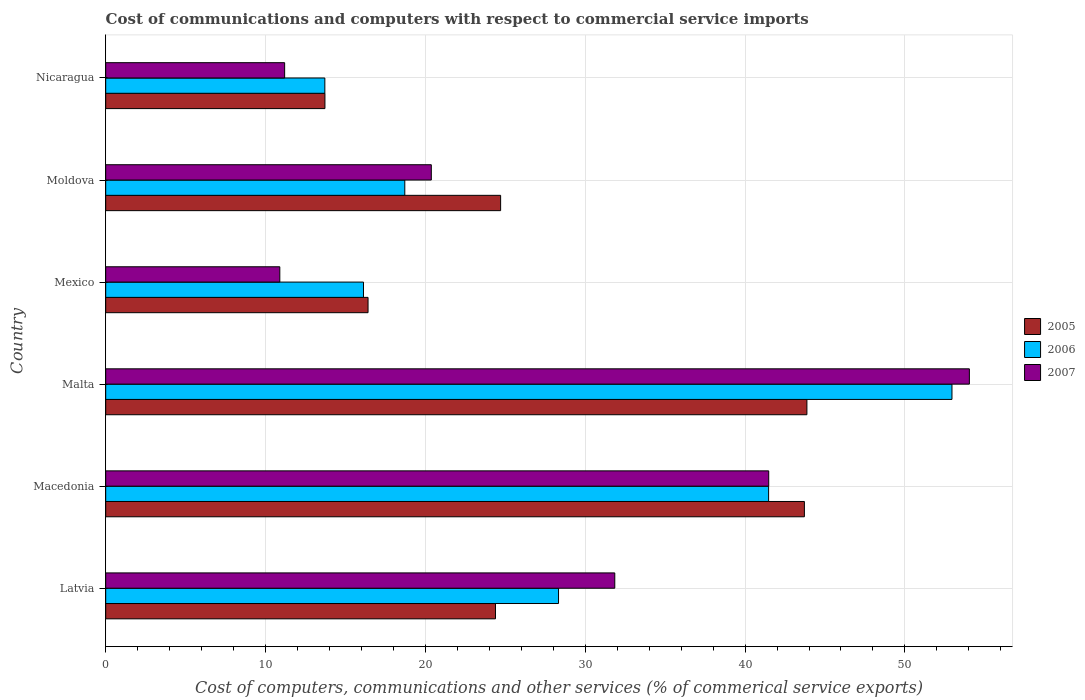What is the label of the 5th group of bars from the top?
Provide a succinct answer. Macedonia. In how many cases, is the number of bars for a given country not equal to the number of legend labels?
Keep it short and to the point. 0. What is the cost of communications and computers in 2007 in Nicaragua?
Make the answer very short. 11.2. Across all countries, what is the maximum cost of communications and computers in 2007?
Your answer should be compact. 54.03. Across all countries, what is the minimum cost of communications and computers in 2005?
Offer a terse response. 13.72. In which country was the cost of communications and computers in 2006 maximum?
Offer a terse response. Malta. What is the total cost of communications and computers in 2006 in the graph?
Offer a terse response. 171.3. What is the difference between the cost of communications and computers in 2005 in Malta and that in Moldova?
Give a very brief answer. 19.16. What is the difference between the cost of communications and computers in 2005 in Nicaragua and the cost of communications and computers in 2007 in Macedonia?
Offer a terse response. -27.76. What is the average cost of communications and computers in 2006 per country?
Keep it short and to the point. 28.55. What is the difference between the cost of communications and computers in 2005 and cost of communications and computers in 2007 in Nicaragua?
Offer a terse response. 2.52. In how many countries, is the cost of communications and computers in 2005 greater than 2 %?
Your response must be concise. 6. What is the ratio of the cost of communications and computers in 2005 in Macedonia to that in Mexico?
Offer a terse response. 2.66. Is the cost of communications and computers in 2005 in Malta less than that in Nicaragua?
Give a very brief answer. No. Is the difference between the cost of communications and computers in 2005 in Malta and Mexico greater than the difference between the cost of communications and computers in 2007 in Malta and Mexico?
Give a very brief answer. No. What is the difference between the highest and the second highest cost of communications and computers in 2007?
Ensure brevity in your answer.  12.55. What is the difference between the highest and the lowest cost of communications and computers in 2005?
Make the answer very short. 30.15. In how many countries, is the cost of communications and computers in 2007 greater than the average cost of communications and computers in 2007 taken over all countries?
Your answer should be very brief. 3. What does the 1st bar from the bottom in Macedonia represents?
Keep it short and to the point. 2005. How many countries are there in the graph?
Your answer should be compact. 6. Are the values on the major ticks of X-axis written in scientific E-notation?
Make the answer very short. No. Does the graph contain any zero values?
Provide a succinct answer. No. Where does the legend appear in the graph?
Your response must be concise. Center right. How many legend labels are there?
Give a very brief answer. 3. How are the legend labels stacked?
Offer a very short reply. Vertical. What is the title of the graph?
Make the answer very short. Cost of communications and computers with respect to commercial service imports. Does "2015" appear as one of the legend labels in the graph?
Offer a terse response. No. What is the label or title of the X-axis?
Make the answer very short. Cost of computers, communications and other services (% of commerical service exports). What is the label or title of the Y-axis?
Make the answer very short. Country. What is the Cost of computers, communications and other services (% of commerical service exports) in 2005 in Latvia?
Keep it short and to the point. 24.39. What is the Cost of computers, communications and other services (% of commerical service exports) of 2006 in Latvia?
Make the answer very short. 28.33. What is the Cost of computers, communications and other services (% of commerical service exports) of 2007 in Latvia?
Give a very brief answer. 31.85. What is the Cost of computers, communications and other services (% of commerical service exports) in 2005 in Macedonia?
Your answer should be very brief. 43.71. What is the Cost of computers, communications and other services (% of commerical service exports) in 2006 in Macedonia?
Keep it short and to the point. 41.47. What is the Cost of computers, communications and other services (% of commerical service exports) of 2007 in Macedonia?
Provide a short and direct response. 41.48. What is the Cost of computers, communications and other services (% of commerical service exports) in 2005 in Malta?
Make the answer very short. 43.87. What is the Cost of computers, communications and other services (% of commerical service exports) in 2006 in Malta?
Keep it short and to the point. 52.94. What is the Cost of computers, communications and other services (% of commerical service exports) of 2007 in Malta?
Your answer should be compact. 54.03. What is the Cost of computers, communications and other services (% of commerical service exports) in 2005 in Mexico?
Provide a short and direct response. 16.41. What is the Cost of computers, communications and other services (% of commerical service exports) of 2006 in Mexico?
Provide a short and direct response. 16.13. What is the Cost of computers, communications and other services (% of commerical service exports) of 2007 in Mexico?
Your response must be concise. 10.89. What is the Cost of computers, communications and other services (% of commerical service exports) in 2005 in Moldova?
Your response must be concise. 24.71. What is the Cost of computers, communications and other services (% of commerical service exports) of 2006 in Moldova?
Give a very brief answer. 18.71. What is the Cost of computers, communications and other services (% of commerical service exports) of 2007 in Moldova?
Provide a short and direct response. 20.37. What is the Cost of computers, communications and other services (% of commerical service exports) of 2005 in Nicaragua?
Your answer should be compact. 13.72. What is the Cost of computers, communications and other services (% of commerical service exports) of 2006 in Nicaragua?
Ensure brevity in your answer.  13.71. What is the Cost of computers, communications and other services (% of commerical service exports) of 2007 in Nicaragua?
Your response must be concise. 11.2. Across all countries, what is the maximum Cost of computers, communications and other services (% of commerical service exports) in 2005?
Your answer should be very brief. 43.87. Across all countries, what is the maximum Cost of computers, communications and other services (% of commerical service exports) of 2006?
Provide a short and direct response. 52.94. Across all countries, what is the maximum Cost of computers, communications and other services (% of commerical service exports) of 2007?
Keep it short and to the point. 54.03. Across all countries, what is the minimum Cost of computers, communications and other services (% of commerical service exports) in 2005?
Provide a succinct answer. 13.72. Across all countries, what is the minimum Cost of computers, communications and other services (% of commerical service exports) in 2006?
Keep it short and to the point. 13.71. Across all countries, what is the minimum Cost of computers, communications and other services (% of commerical service exports) of 2007?
Provide a short and direct response. 10.89. What is the total Cost of computers, communications and other services (% of commerical service exports) of 2005 in the graph?
Your answer should be very brief. 166.8. What is the total Cost of computers, communications and other services (% of commerical service exports) of 2006 in the graph?
Give a very brief answer. 171.3. What is the total Cost of computers, communications and other services (% of commerical service exports) of 2007 in the graph?
Keep it short and to the point. 169.82. What is the difference between the Cost of computers, communications and other services (% of commerical service exports) of 2005 in Latvia and that in Macedonia?
Your answer should be very brief. -19.32. What is the difference between the Cost of computers, communications and other services (% of commerical service exports) in 2006 in Latvia and that in Macedonia?
Offer a very short reply. -13.14. What is the difference between the Cost of computers, communications and other services (% of commerical service exports) of 2007 in Latvia and that in Macedonia?
Ensure brevity in your answer.  -9.63. What is the difference between the Cost of computers, communications and other services (% of commerical service exports) of 2005 in Latvia and that in Malta?
Your response must be concise. -19.48. What is the difference between the Cost of computers, communications and other services (% of commerical service exports) in 2006 in Latvia and that in Malta?
Keep it short and to the point. -24.61. What is the difference between the Cost of computers, communications and other services (% of commerical service exports) in 2007 in Latvia and that in Malta?
Provide a short and direct response. -22.18. What is the difference between the Cost of computers, communications and other services (% of commerical service exports) in 2005 in Latvia and that in Mexico?
Give a very brief answer. 7.97. What is the difference between the Cost of computers, communications and other services (% of commerical service exports) in 2006 in Latvia and that in Mexico?
Your answer should be very brief. 12.2. What is the difference between the Cost of computers, communications and other services (% of commerical service exports) in 2007 in Latvia and that in Mexico?
Make the answer very short. 20.96. What is the difference between the Cost of computers, communications and other services (% of commerical service exports) in 2005 in Latvia and that in Moldova?
Provide a short and direct response. -0.32. What is the difference between the Cost of computers, communications and other services (% of commerical service exports) in 2006 in Latvia and that in Moldova?
Your answer should be very brief. 9.62. What is the difference between the Cost of computers, communications and other services (% of commerical service exports) of 2007 in Latvia and that in Moldova?
Offer a terse response. 11.48. What is the difference between the Cost of computers, communications and other services (% of commerical service exports) of 2005 in Latvia and that in Nicaragua?
Keep it short and to the point. 10.67. What is the difference between the Cost of computers, communications and other services (% of commerical service exports) of 2006 in Latvia and that in Nicaragua?
Offer a very short reply. 14.62. What is the difference between the Cost of computers, communications and other services (% of commerical service exports) of 2007 in Latvia and that in Nicaragua?
Provide a succinct answer. 20.65. What is the difference between the Cost of computers, communications and other services (% of commerical service exports) in 2005 in Macedonia and that in Malta?
Offer a very short reply. -0.16. What is the difference between the Cost of computers, communications and other services (% of commerical service exports) of 2006 in Macedonia and that in Malta?
Your response must be concise. -11.47. What is the difference between the Cost of computers, communications and other services (% of commerical service exports) of 2007 in Macedonia and that in Malta?
Ensure brevity in your answer.  -12.55. What is the difference between the Cost of computers, communications and other services (% of commerical service exports) in 2005 in Macedonia and that in Mexico?
Your answer should be compact. 27.3. What is the difference between the Cost of computers, communications and other services (% of commerical service exports) in 2006 in Macedonia and that in Mexico?
Keep it short and to the point. 25.35. What is the difference between the Cost of computers, communications and other services (% of commerical service exports) in 2007 in Macedonia and that in Mexico?
Provide a short and direct response. 30.59. What is the difference between the Cost of computers, communications and other services (% of commerical service exports) in 2005 in Macedonia and that in Moldova?
Your answer should be compact. 19. What is the difference between the Cost of computers, communications and other services (% of commerical service exports) in 2006 in Macedonia and that in Moldova?
Your answer should be very brief. 22.76. What is the difference between the Cost of computers, communications and other services (% of commerical service exports) in 2007 in Macedonia and that in Moldova?
Your response must be concise. 21.11. What is the difference between the Cost of computers, communications and other services (% of commerical service exports) of 2005 in Macedonia and that in Nicaragua?
Your answer should be compact. 30. What is the difference between the Cost of computers, communications and other services (% of commerical service exports) of 2006 in Macedonia and that in Nicaragua?
Give a very brief answer. 27.76. What is the difference between the Cost of computers, communications and other services (% of commerical service exports) in 2007 in Macedonia and that in Nicaragua?
Your response must be concise. 30.29. What is the difference between the Cost of computers, communications and other services (% of commerical service exports) in 2005 in Malta and that in Mexico?
Give a very brief answer. 27.46. What is the difference between the Cost of computers, communications and other services (% of commerical service exports) in 2006 in Malta and that in Mexico?
Your answer should be very brief. 36.82. What is the difference between the Cost of computers, communications and other services (% of commerical service exports) of 2007 in Malta and that in Mexico?
Your answer should be very brief. 43.14. What is the difference between the Cost of computers, communications and other services (% of commerical service exports) in 2005 in Malta and that in Moldova?
Give a very brief answer. 19.16. What is the difference between the Cost of computers, communications and other services (% of commerical service exports) of 2006 in Malta and that in Moldova?
Offer a very short reply. 34.23. What is the difference between the Cost of computers, communications and other services (% of commerical service exports) in 2007 in Malta and that in Moldova?
Your answer should be compact. 33.66. What is the difference between the Cost of computers, communications and other services (% of commerical service exports) in 2005 in Malta and that in Nicaragua?
Provide a succinct answer. 30.15. What is the difference between the Cost of computers, communications and other services (% of commerical service exports) of 2006 in Malta and that in Nicaragua?
Give a very brief answer. 39.23. What is the difference between the Cost of computers, communications and other services (% of commerical service exports) of 2007 in Malta and that in Nicaragua?
Provide a short and direct response. 42.84. What is the difference between the Cost of computers, communications and other services (% of commerical service exports) of 2005 in Mexico and that in Moldova?
Provide a short and direct response. -8.29. What is the difference between the Cost of computers, communications and other services (% of commerical service exports) in 2006 in Mexico and that in Moldova?
Give a very brief answer. -2.58. What is the difference between the Cost of computers, communications and other services (% of commerical service exports) in 2007 in Mexico and that in Moldova?
Your answer should be very brief. -9.48. What is the difference between the Cost of computers, communications and other services (% of commerical service exports) of 2005 in Mexico and that in Nicaragua?
Give a very brief answer. 2.7. What is the difference between the Cost of computers, communications and other services (% of commerical service exports) in 2006 in Mexico and that in Nicaragua?
Make the answer very short. 2.42. What is the difference between the Cost of computers, communications and other services (% of commerical service exports) of 2007 in Mexico and that in Nicaragua?
Your answer should be compact. -0.3. What is the difference between the Cost of computers, communications and other services (% of commerical service exports) in 2005 in Moldova and that in Nicaragua?
Keep it short and to the point. 10.99. What is the difference between the Cost of computers, communications and other services (% of commerical service exports) of 2006 in Moldova and that in Nicaragua?
Provide a succinct answer. 5. What is the difference between the Cost of computers, communications and other services (% of commerical service exports) of 2007 in Moldova and that in Nicaragua?
Offer a terse response. 9.18. What is the difference between the Cost of computers, communications and other services (% of commerical service exports) of 2005 in Latvia and the Cost of computers, communications and other services (% of commerical service exports) of 2006 in Macedonia?
Offer a terse response. -17.09. What is the difference between the Cost of computers, communications and other services (% of commerical service exports) in 2005 in Latvia and the Cost of computers, communications and other services (% of commerical service exports) in 2007 in Macedonia?
Your response must be concise. -17.09. What is the difference between the Cost of computers, communications and other services (% of commerical service exports) of 2006 in Latvia and the Cost of computers, communications and other services (% of commerical service exports) of 2007 in Macedonia?
Ensure brevity in your answer.  -13.15. What is the difference between the Cost of computers, communications and other services (% of commerical service exports) in 2005 in Latvia and the Cost of computers, communications and other services (% of commerical service exports) in 2006 in Malta?
Provide a succinct answer. -28.56. What is the difference between the Cost of computers, communications and other services (% of commerical service exports) of 2005 in Latvia and the Cost of computers, communications and other services (% of commerical service exports) of 2007 in Malta?
Give a very brief answer. -29.65. What is the difference between the Cost of computers, communications and other services (% of commerical service exports) in 2006 in Latvia and the Cost of computers, communications and other services (% of commerical service exports) in 2007 in Malta?
Provide a short and direct response. -25.7. What is the difference between the Cost of computers, communications and other services (% of commerical service exports) in 2005 in Latvia and the Cost of computers, communications and other services (% of commerical service exports) in 2006 in Mexico?
Keep it short and to the point. 8.26. What is the difference between the Cost of computers, communications and other services (% of commerical service exports) in 2005 in Latvia and the Cost of computers, communications and other services (% of commerical service exports) in 2007 in Mexico?
Offer a terse response. 13.49. What is the difference between the Cost of computers, communications and other services (% of commerical service exports) in 2006 in Latvia and the Cost of computers, communications and other services (% of commerical service exports) in 2007 in Mexico?
Make the answer very short. 17.44. What is the difference between the Cost of computers, communications and other services (% of commerical service exports) of 2005 in Latvia and the Cost of computers, communications and other services (% of commerical service exports) of 2006 in Moldova?
Give a very brief answer. 5.67. What is the difference between the Cost of computers, communications and other services (% of commerical service exports) of 2005 in Latvia and the Cost of computers, communications and other services (% of commerical service exports) of 2007 in Moldova?
Offer a very short reply. 4.02. What is the difference between the Cost of computers, communications and other services (% of commerical service exports) of 2006 in Latvia and the Cost of computers, communications and other services (% of commerical service exports) of 2007 in Moldova?
Offer a terse response. 7.96. What is the difference between the Cost of computers, communications and other services (% of commerical service exports) of 2005 in Latvia and the Cost of computers, communications and other services (% of commerical service exports) of 2006 in Nicaragua?
Ensure brevity in your answer.  10.68. What is the difference between the Cost of computers, communications and other services (% of commerical service exports) of 2005 in Latvia and the Cost of computers, communications and other services (% of commerical service exports) of 2007 in Nicaragua?
Make the answer very short. 13.19. What is the difference between the Cost of computers, communications and other services (% of commerical service exports) in 2006 in Latvia and the Cost of computers, communications and other services (% of commerical service exports) in 2007 in Nicaragua?
Your answer should be compact. 17.14. What is the difference between the Cost of computers, communications and other services (% of commerical service exports) of 2005 in Macedonia and the Cost of computers, communications and other services (% of commerical service exports) of 2006 in Malta?
Offer a very short reply. -9.23. What is the difference between the Cost of computers, communications and other services (% of commerical service exports) in 2005 in Macedonia and the Cost of computers, communications and other services (% of commerical service exports) in 2007 in Malta?
Offer a very short reply. -10.32. What is the difference between the Cost of computers, communications and other services (% of commerical service exports) of 2006 in Macedonia and the Cost of computers, communications and other services (% of commerical service exports) of 2007 in Malta?
Your response must be concise. -12.56. What is the difference between the Cost of computers, communications and other services (% of commerical service exports) in 2005 in Macedonia and the Cost of computers, communications and other services (% of commerical service exports) in 2006 in Mexico?
Ensure brevity in your answer.  27.58. What is the difference between the Cost of computers, communications and other services (% of commerical service exports) in 2005 in Macedonia and the Cost of computers, communications and other services (% of commerical service exports) in 2007 in Mexico?
Give a very brief answer. 32.82. What is the difference between the Cost of computers, communications and other services (% of commerical service exports) of 2006 in Macedonia and the Cost of computers, communications and other services (% of commerical service exports) of 2007 in Mexico?
Keep it short and to the point. 30.58. What is the difference between the Cost of computers, communications and other services (% of commerical service exports) in 2005 in Macedonia and the Cost of computers, communications and other services (% of commerical service exports) in 2006 in Moldova?
Offer a very short reply. 25. What is the difference between the Cost of computers, communications and other services (% of commerical service exports) of 2005 in Macedonia and the Cost of computers, communications and other services (% of commerical service exports) of 2007 in Moldova?
Make the answer very short. 23.34. What is the difference between the Cost of computers, communications and other services (% of commerical service exports) of 2006 in Macedonia and the Cost of computers, communications and other services (% of commerical service exports) of 2007 in Moldova?
Make the answer very short. 21.1. What is the difference between the Cost of computers, communications and other services (% of commerical service exports) of 2005 in Macedonia and the Cost of computers, communications and other services (% of commerical service exports) of 2006 in Nicaragua?
Provide a succinct answer. 30. What is the difference between the Cost of computers, communications and other services (% of commerical service exports) in 2005 in Macedonia and the Cost of computers, communications and other services (% of commerical service exports) in 2007 in Nicaragua?
Offer a very short reply. 32.52. What is the difference between the Cost of computers, communications and other services (% of commerical service exports) of 2006 in Macedonia and the Cost of computers, communications and other services (% of commerical service exports) of 2007 in Nicaragua?
Keep it short and to the point. 30.28. What is the difference between the Cost of computers, communications and other services (% of commerical service exports) of 2005 in Malta and the Cost of computers, communications and other services (% of commerical service exports) of 2006 in Mexico?
Your answer should be compact. 27.74. What is the difference between the Cost of computers, communications and other services (% of commerical service exports) in 2005 in Malta and the Cost of computers, communications and other services (% of commerical service exports) in 2007 in Mexico?
Offer a very short reply. 32.98. What is the difference between the Cost of computers, communications and other services (% of commerical service exports) in 2006 in Malta and the Cost of computers, communications and other services (% of commerical service exports) in 2007 in Mexico?
Offer a terse response. 42.05. What is the difference between the Cost of computers, communications and other services (% of commerical service exports) of 2005 in Malta and the Cost of computers, communications and other services (% of commerical service exports) of 2006 in Moldova?
Give a very brief answer. 25.16. What is the difference between the Cost of computers, communications and other services (% of commerical service exports) of 2005 in Malta and the Cost of computers, communications and other services (% of commerical service exports) of 2007 in Moldova?
Offer a very short reply. 23.5. What is the difference between the Cost of computers, communications and other services (% of commerical service exports) in 2006 in Malta and the Cost of computers, communications and other services (% of commerical service exports) in 2007 in Moldova?
Provide a succinct answer. 32.57. What is the difference between the Cost of computers, communications and other services (% of commerical service exports) of 2005 in Malta and the Cost of computers, communications and other services (% of commerical service exports) of 2006 in Nicaragua?
Make the answer very short. 30.16. What is the difference between the Cost of computers, communications and other services (% of commerical service exports) of 2005 in Malta and the Cost of computers, communications and other services (% of commerical service exports) of 2007 in Nicaragua?
Ensure brevity in your answer.  32.67. What is the difference between the Cost of computers, communications and other services (% of commerical service exports) in 2006 in Malta and the Cost of computers, communications and other services (% of commerical service exports) in 2007 in Nicaragua?
Provide a succinct answer. 41.75. What is the difference between the Cost of computers, communications and other services (% of commerical service exports) of 2005 in Mexico and the Cost of computers, communications and other services (% of commerical service exports) of 2006 in Moldova?
Offer a very short reply. -2.3. What is the difference between the Cost of computers, communications and other services (% of commerical service exports) in 2005 in Mexico and the Cost of computers, communications and other services (% of commerical service exports) in 2007 in Moldova?
Your response must be concise. -3.96. What is the difference between the Cost of computers, communications and other services (% of commerical service exports) of 2006 in Mexico and the Cost of computers, communications and other services (% of commerical service exports) of 2007 in Moldova?
Offer a terse response. -4.24. What is the difference between the Cost of computers, communications and other services (% of commerical service exports) in 2005 in Mexico and the Cost of computers, communications and other services (% of commerical service exports) in 2006 in Nicaragua?
Your answer should be compact. 2.7. What is the difference between the Cost of computers, communications and other services (% of commerical service exports) in 2005 in Mexico and the Cost of computers, communications and other services (% of commerical service exports) in 2007 in Nicaragua?
Give a very brief answer. 5.22. What is the difference between the Cost of computers, communications and other services (% of commerical service exports) of 2006 in Mexico and the Cost of computers, communications and other services (% of commerical service exports) of 2007 in Nicaragua?
Offer a terse response. 4.93. What is the difference between the Cost of computers, communications and other services (% of commerical service exports) in 2005 in Moldova and the Cost of computers, communications and other services (% of commerical service exports) in 2006 in Nicaragua?
Make the answer very short. 11. What is the difference between the Cost of computers, communications and other services (% of commerical service exports) of 2005 in Moldova and the Cost of computers, communications and other services (% of commerical service exports) of 2007 in Nicaragua?
Your response must be concise. 13.51. What is the difference between the Cost of computers, communications and other services (% of commerical service exports) of 2006 in Moldova and the Cost of computers, communications and other services (% of commerical service exports) of 2007 in Nicaragua?
Provide a succinct answer. 7.52. What is the average Cost of computers, communications and other services (% of commerical service exports) of 2005 per country?
Offer a terse response. 27.8. What is the average Cost of computers, communications and other services (% of commerical service exports) in 2006 per country?
Keep it short and to the point. 28.55. What is the average Cost of computers, communications and other services (% of commerical service exports) of 2007 per country?
Provide a short and direct response. 28.3. What is the difference between the Cost of computers, communications and other services (% of commerical service exports) of 2005 and Cost of computers, communications and other services (% of commerical service exports) of 2006 in Latvia?
Ensure brevity in your answer.  -3.94. What is the difference between the Cost of computers, communications and other services (% of commerical service exports) of 2005 and Cost of computers, communications and other services (% of commerical service exports) of 2007 in Latvia?
Your answer should be compact. -7.46. What is the difference between the Cost of computers, communications and other services (% of commerical service exports) of 2006 and Cost of computers, communications and other services (% of commerical service exports) of 2007 in Latvia?
Provide a short and direct response. -3.52. What is the difference between the Cost of computers, communications and other services (% of commerical service exports) of 2005 and Cost of computers, communications and other services (% of commerical service exports) of 2006 in Macedonia?
Your answer should be compact. 2.24. What is the difference between the Cost of computers, communications and other services (% of commerical service exports) in 2005 and Cost of computers, communications and other services (% of commerical service exports) in 2007 in Macedonia?
Provide a short and direct response. 2.23. What is the difference between the Cost of computers, communications and other services (% of commerical service exports) in 2006 and Cost of computers, communications and other services (% of commerical service exports) in 2007 in Macedonia?
Your answer should be very brief. -0.01. What is the difference between the Cost of computers, communications and other services (% of commerical service exports) of 2005 and Cost of computers, communications and other services (% of commerical service exports) of 2006 in Malta?
Your answer should be very brief. -9.08. What is the difference between the Cost of computers, communications and other services (% of commerical service exports) of 2005 and Cost of computers, communications and other services (% of commerical service exports) of 2007 in Malta?
Offer a terse response. -10.16. What is the difference between the Cost of computers, communications and other services (% of commerical service exports) in 2006 and Cost of computers, communications and other services (% of commerical service exports) in 2007 in Malta?
Your answer should be compact. -1.09. What is the difference between the Cost of computers, communications and other services (% of commerical service exports) in 2005 and Cost of computers, communications and other services (% of commerical service exports) in 2006 in Mexico?
Keep it short and to the point. 0.29. What is the difference between the Cost of computers, communications and other services (% of commerical service exports) of 2005 and Cost of computers, communications and other services (% of commerical service exports) of 2007 in Mexico?
Offer a terse response. 5.52. What is the difference between the Cost of computers, communications and other services (% of commerical service exports) in 2006 and Cost of computers, communications and other services (% of commerical service exports) in 2007 in Mexico?
Keep it short and to the point. 5.23. What is the difference between the Cost of computers, communications and other services (% of commerical service exports) of 2005 and Cost of computers, communications and other services (% of commerical service exports) of 2006 in Moldova?
Provide a short and direct response. 6. What is the difference between the Cost of computers, communications and other services (% of commerical service exports) in 2005 and Cost of computers, communications and other services (% of commerical service exports) in 2007 in Moldova?
Offer a very short reply. 4.34. What is the difference between the Cost of computers, communications and other services (% of commerical service exports) of 2006 and Cost of computers, communications and other services (% of commerical service exports) of 2007 in Moldova?
Give a very brief answer. -1.66. What is the difference between the Cost of computers, communications and other services (% of commerical service exports) of 2005 and Cost of computers, communications and other services (% of commerical service exports) of 2006 in Nicaragua?
Offer a terse response. 0.01. What is the difference between the Cost of computers, communications and other services (% of commerical service exports) of 2005 and Cost of computers, communications and other services (% of commerical service exports) of 2007 in Nicaragua?
Offer a terse response. 2.52. What is the difference between the Cost of computers, communications and other services (% of commerical service exports) of 2006 and Cost of computers, communications and other services (% of commerical service exports) of 2007 in Nicaragua?
Keep it short and to the point. 2.52. What is the ratio of the Cost of computers, communications and other services (% of commerical service exports) of 2005 in Latvia to that in Macedonia?
Keep it short and to the point. 0.56. What is the ratio of the Cost of computers, communications and other services (% of commerical service exports) in 2006 in Latvia to that in Macedonia?
Offer a terse response. 0.68. What is the ratio of the Cost of computers, communications and other services (% of commerical service exports) of 2007 in Latvia to that in Macedonia?
Your answer should be very brief. 0.77. What is the ratio of the Cost of computers, communications and other services (% of commerical service exports) in 2005 in Latvia to that in Malta?
Offer a very short reply. 0.56. What is the ratio of the Cost of computers, communications and other services (% of commerical service exports) in 2006 in Latvia to that in Malta?
Provide a succinct answer. 0.54. What is the ratio of the Cost of computers, communications and other services (% of commerical service exports) of 2007 in Latvia to that in Malta?
Your response must be concise. 0.59. What is the ratio of the Cost of computers, communications and other services (% of commerical service exports) of 2005 in Latvia to that in Mexico?
Provide a succinct answer. 1.49. What is the ratio of the Cost of computers, communications and other services (% of commerical service exports) in 2006 in Latvia to that in Mexico?
Provide a short and direct response. 1.76. What is the ratio of the Cost of computers, communications and other services (% of commerical service exports) in 2007 in Latvia to that in Mexico?
Your answer should be very brief. 2.92. What is the ratio of the Cost of computers, communications and other services (% of commerical service exports) of 2005 in Latvia to that in Moldova?
Provide a succinct answer. 0.99. What is the ratio of the Cost of computers, communications and other services (% of commerical service exports) of 2006 in Latvia to that in Moldova?
Offer a terse response. 1.51. What is the ratio of the Cost of computers, communications and other services (% of commerical service exports) in 2007 in Latvia to that in Moldova?
Your answer should be compact. 1.56. What is the ratio of the Cost of computers, communications and other services (% of commerical service exports) in 2005 in Latvia to that in Nicaragua?
Your answer should be compact. 1.78. What is the ratio of the Cost of computers, communications and other services (% of commerical service exports) of 2006 in Latvia to that in Nicaragua?
Offer a terse response. 2.07. What is the ratio of the Cost of computers, communications and other services (% of commerical service exports) in 2007 in Latvia to that in Nicaragua?
Keep it short and to the point. 2.84. What is the ratio of the Cost of computers, communications and other services (% of commerical service exports) in 2005 in Macedonia to that in Malta?
Ensure brevity in your answer.  1. What is the ratio of the Cost of computers, communications and other services (% of commerical service exports) of 2006 in Macedonia to that in Malta?
Ensure brevity in your answer.  0.78. What is the ratio of the Cost of computers, communications and other services (% of commerical service exports) in 2007 in Macedonia to that in Malta?
Make the answer very short. 0.77. What is the ratio of the Cost of computers, communications and other services (% of commerical service exports) of 2005 in Macedonia to that in Mexico?
Offer a very short reply. 2.66. What is the ratio of the Cost of computers, communications and other services (% of commerical service exports) of 2006 in Macedonia to that in Mexico?
Your answer should be very brief. 2.57. What is the ratio of the Cost of computers, communications and other services (% of commerical service exports) of 2007 in Macedonia to that in Mexico?
Ensure brevity in your answer.  3.81. What is the ratio of the Cost of computers, communications and other services (% of commerical service exports) in 2005 in Macedonia to that in Moldova?
Give a very brief answer. 1.77. What is the ratio of the Cost of computers, communications and other services (% of commerical service exports) of 2006 in Macedonia to that in Moldova?
Your response must be concise. 2.22. What is the ratio of the Cost of computers, communications and other services (% of commerical service exports) of 2007 in Macedonia to that in Moldova?
Your answer should be compact. 2.04. What is the ratio of the Cost of computers, communications and other services (% of commerical service exports) in 2005 in Macedonia to that in Nicaragua?
Keep it short and to the point. 3.19. What is the ratio of the Cost of computers, communications and other services (% of commerical service exports) in 2006 in Macedonia to that in Nicaragua?
Offer a very short reply. 3.02. What is the ratio of the Cost of computers, communications and other services (% of commerical service exports) of 2007 in Macedonia to that in Nicaragua?
Your answer should be compact. 3.71. What is the ratio of the Cost of computers, communications and other services (% of commerical service exports) in 2005 in Malta to that in Mexico?
Provide a short and direct response. 2.67. What is the ratio of the Cost of computers, communications and other services (% of commerical service exports) in 2006 in Malta to that in Mexico?
Provide a short and direct response. 3.28. What is the ratio of the Cost of computers, communications and other services (% of commerical service exports) in 2007 in Malta to that in Mexico?
Provide a succinct answer. 4.96. What is the ratio of the Cost of computers, communications and other services (% of commerical service exports) of 2005 in Malta to that in Moldova?
Your answer should be very brief. 1.78. What is the ratio of the Cost of computers, communications and other services (% of commerical service exports) in 2006 in Malta to that in Moldova?
Provide a succinct answer. 2.83. What is the ratio of the Cost of computers, communications and other services (% of commerical service exports) in 2007 in Malta to that in Moldova?
Provide a short and direct response. 2.65. What is the ratio of the Cost of computers, communications and other services (% of commerical service exports) of 2005 in Malta to that in Nicaragua?
Keep it short and to the point. 3.2. What is the ratio of the Cost of computers, communications and other services (% of commerical service exports) in 2006 in Malta to that in Nicaragua?
Keep it short and to the point. 3.86. What is the ratio of the Cost of computers, communications and other services (% of commerical service exports) of 2007 in Malta to that in Nicaragua?
Keep it short and to the point. 4.83. What is the ratio of the Cost of computers, communications and other services (% of commerical service exports) in 2005 in Mexico to that in Moldova?
Provide a succinct answer. 0.66. What is the ratio of the Cost of computers, communications and other services (% of commerical service exports) in 2006 in Mexico to that in Moldova?
Ensure brevity in your answer.  0.86. What is the ratio of the Cost of computers, communications and other services (% of commerical service exports) of 2007 in Mexico to that in Moldova?
Give a very brief answer. 0.53. What is the ratio of the Cost of computers, communications and other services (% of commerical service exports) of 2005 in Mexico to that in Nicaragua?
Your answer should be very brief. 1.2. What is the ratio of the Cost of computers, communications and other services (% of commerical service exports) of 2006 in Mexico to that in Nicaragua?
Ensure brevity in your answer.  1.18. What is the ratio of the Cost of computers, communications and other services (% of commerical service exports) in 2005 in Moldova to that in Nicaragua?
Give a very brief answer. 1.8. What is the ratio of the Cost of computers, communications and other services (% of commerical service exports) in 2006 in Moldova to that in Nicaragua?
Make the answer very short. 1.36. What is the ratio of the Cost of computers, communications and other services (% of commerical service exports) in 2007 in Moldova to that in Nicaragua?
Offer a terse response. 1.82. What is the difference between the highest and the second highest Cost of computers, communications and other services (% of commerical service exports) of 2005?
Offer a terse response. 0.16. What is the difference between the highest and the second highest Cost of computers, communications and other services (% of commerical service exports) in 2006?
Provide a succinct answer. 11.47. What is the difference between the highest and the second highest Cost of computers, communications and other services (% of commerical service exports) in 2007?
Your answer should be very brief. 12.55. What is the difference between the highest and the lowest Cost of computers, communications and other services (% of commerical service exports) in 2005?
Offer a terse response. 30.15. What is the difference between the highest and the lowest Cost of computers, communications and other services (% of commerical service exports) of 2006?
Offer a terse response. 39.23. What is the difference between the highest and the lowest Cost of computers, communications and other services (% of commerical service exports) in 2007?
Offer a terse response. 43.14. 